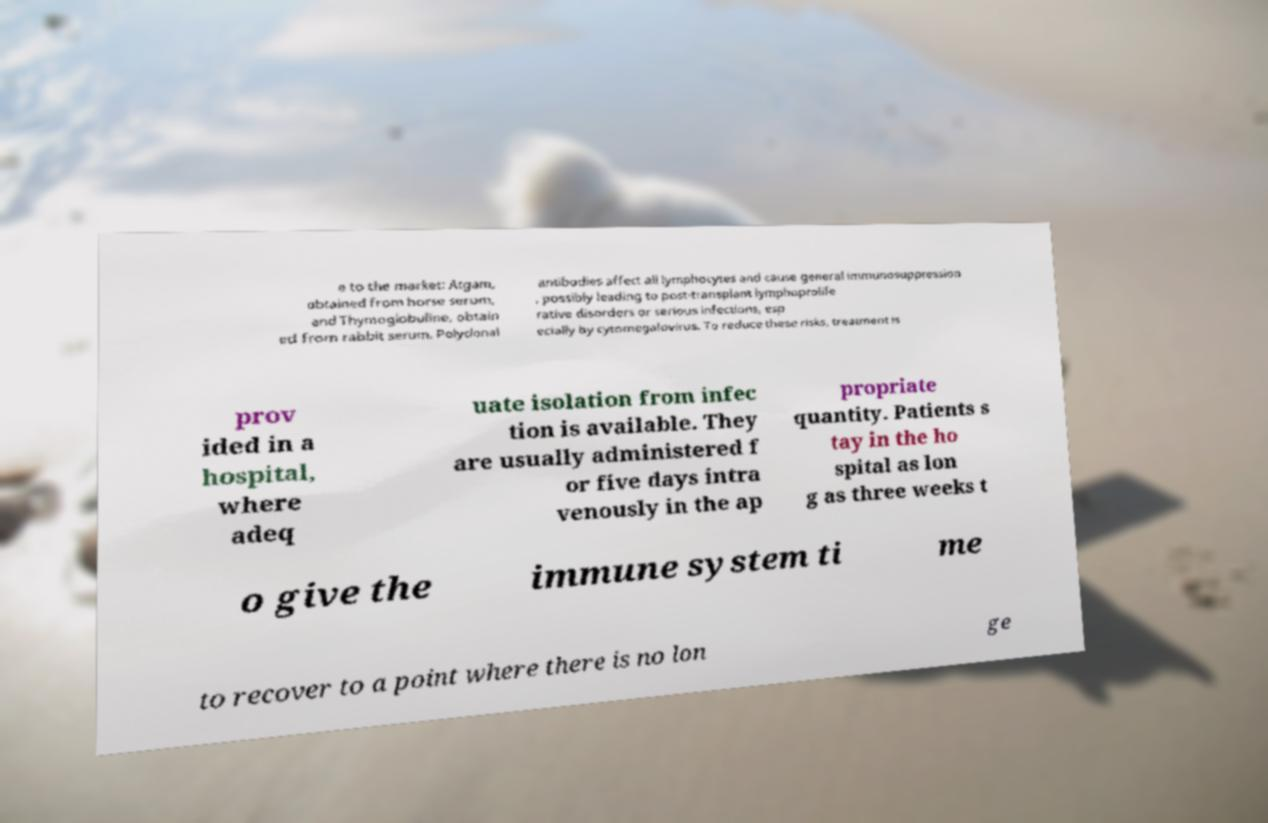For documentation purposes, I need the text within this image transcribed. Could you provide that? e to the market: Atgam, obtained from horse serum, and Thymoglobuline, obtain ed from rabbit serum. Polyclonal antibodies affect all lymphocytes and cause general immunosuppression , possibly leading to post-transplant lymphoprolife rative disorders or serious infections, esp ecially by cytomegalovirus. To reduce these risks, treatment is prov ided in a hospital, where adeq uate isolation from infec tion is available. They are usually administered f or five days intra venously in the ap propriate quantity. Patients s tay in the ho spital as lon g as three weeks t o give the immune system ti me to recover to a point where there is no lon ge 